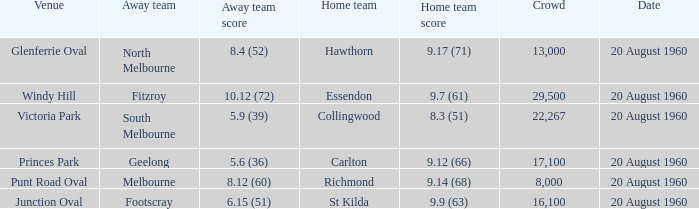What is the venue when Geelong is the away team? Princes Park. 